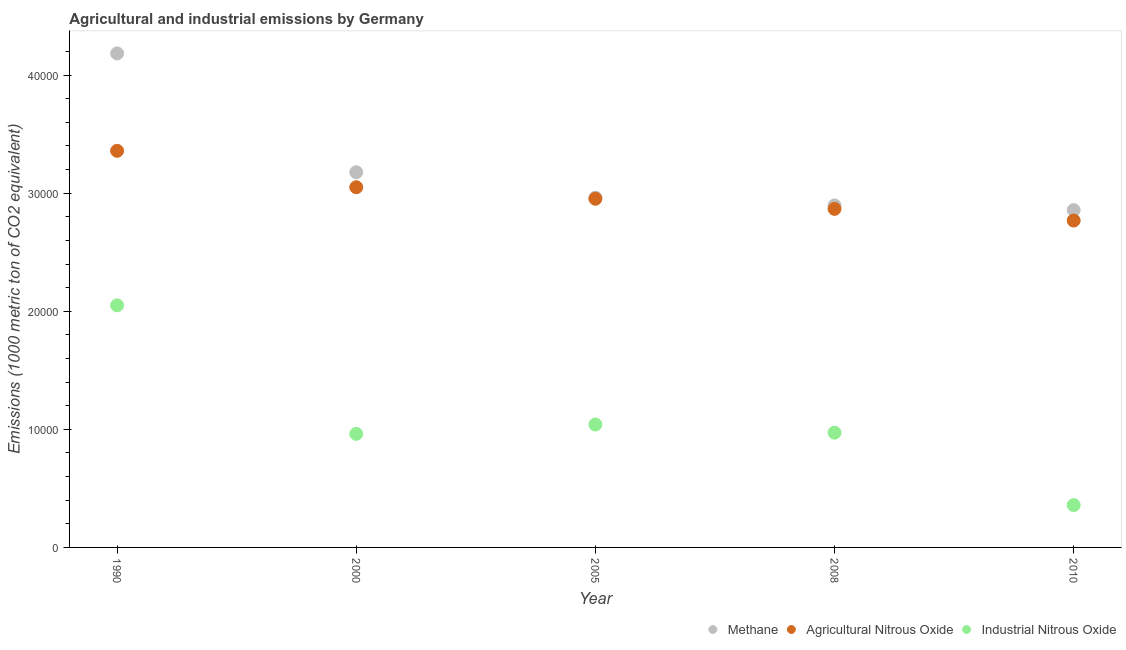What is the amount of agricultural nitrous oxide emissions in 2010?
Offer a very short reply. 2.77e+04. Across all years, what is the maximum amount of agricultural nitrous oxide emissions?
Ensure brevity in your answer.  3.36e+04. Across all years, what is the minimum amount of industrial nitrous oxide emissions?
Offer a very short reply. 3585.4. What is the total amount of agricultural nitrous oxide emissions in the graph?
Your answer should be very brief. 1.50e+05. What is the difference between the amount of agricultural nitrous oxide emissions in 2000 and that in 2005?
Your answer should be compact. 972.5. What is the difference between the amount of agricultural nitrous oxide emissions in 2000 and the amount of industrial nitrous oxide emissions in 2005?
Provide a succinct answer. 2.01e+04. What is the average amount of methane emissions per year?
Give a very brief answer. 3.21e+04. In the year 1990, what is the difference between the amount of industrial nitrous oxide emissions and amount of methane emissions?
Your response must be concise. -2.13e+04. In how many years, is the amount of agricultural nitrous oxide emissions greater than 2000 metric ton?
Offer a very short reply. 5. What is the ratio of the amount of industrial nitrous oxide emissions in 2005 to that in 2010?
Make the answer very short. 2.9. Is the difference between the amount of agricultural nitrous oxide emissions in 1990 and 2000 greater than the difference between the amount of methane emissions in 1990 and 2000?
Your response must be concise. No. What is the difference between the highest and the second highest amount of industrial nitrous oxide emissions?
Your answer should be compact. 1.01e+04. What is the difference between the highest and the lowest amount of industrial nitrous oxide emissions?
Provide a short and direct response. 1.69e+04. In how many years, is the amount of agricultural nitrous oxide emissions greater than the average amount of agricultural nitrous oxide emissions taken over all years?
Provide a short and direct response. 2. Is the sum of the amount of agricultural nitrous oxide emissions in 2000 and 2008 greater than the maximum amount of industrial nitrous oxide emissions across all years?
Make the answer very short. Yes. Is the amount of industrial nitrous oxide emissions strictly greater than the amount of agricultural nitrous oxide emissions over the years?
Give a very brief answer. No. How many dotlines are there?
Keep it short and to the point. 3. Where does the legend appear in the graph?
Ensure brevity in your answer.  Bottom right. How many legend labels are there?
Make the answer very short. 3. What is the title of the graph?
Your answer should be very brief. Agricultural and industrial emissions by Germany. Does "Non-communicable diseases" appear as one of the legend labels in the graph?
Your answer should be compact. No. What is the label or title of the Y-axis?
Make the answer very short. Emissions (1000 metric ton of CO2 equivalent). What is the Emissions (1000 metric ton of CO2 equivalent) of Methane in 1990?
Offer a terse response. 4.18e+04. What is the Emissions (1000 metric ton of CO2 equivalent) in Agricultural Nitrous Oxide in 1990?
Provide a succinct answer. 3.36e+04. What is the Emissions (1000 metric ton of CO2 equivalent) in Industrial Nitrous Oxide in 1990?
Your answer should be compact. 2.05e+04. What is the Emissions (1000 metric ton of CO2 equivalent) of Methane in 2000?
Offer a terse response. 3.18e+04. What is the Emissions (1000 metric ton of CO2 equivalent) of Agricultural Nitrous Oxide in 2000?
Offer a terse response. 3.05e+04. What is the Emissions (1000 metric ton of CO2 equivalent) of Industrial Nitrous Oxide in 2000?
Offer a very short reply. 9617.9. What is the Emissions (1000 metric ton of CO2 equivalent) of Methane in 2005?
Your answer should be compact. 2.96e+04. What is the Emissions (1000 metric ton of CO2 equivalent) of Agricultural Nitrous Oxide in 2005?
Keep it short and to the point. 2.95e+04. What is the Emissions (1000 metric ton of CO2 equivalent) in Industrial Nitrous Oxide in 2005?
Provide a short and direct response. 1.04e+04. What is the Emissions (1000 metric ton of CO2 equivalent) in Methane in 2008?
Give a very brief answer. 2.90e+04. What is the Emissions (1000 metric ton of CO2 equivalent) of Agricultural Nitrous Oxide in 2008?
Offer a very short reply. 2.87e+04. What is the Emissions (1000 metric ton of CO2 equivalent) in Industrial Nitrous Oxide in 2008?
Ensure brevity in your answer.  9718.4. What is the Emissions (1000 metric ton of CO2 equivalent) in Methane in 2010?
Offer a terse response. 2.86e+04. What is the Emissions (1000 metric ton of CO2 equivalent) in Agricultural Nitrous Oxide in 2010?
Provide a succinct answer. 2.77e+04. What is the Emissions (1000 metric ton of CO2 equivalent) of Industrial Nitrous Oxide in 2010?
Provide a short and direct response. 3585.4. Across all years, what is the maximum Emissions (1000 metric ton of CO2 equivalent) of Methane?
Provide a short and direct response. 4.18e+04. Across all years, what is the maximum Emissions (1000 metric ton of CO2 equivalent) in Agricultural Nitrous Oxide?
Your response must be concise. 3.36e+04. Across all years, what is the maximum Emissions (1000 metric ton of CO2 equivalent) of Industrial Nitrous Oxide?
Give a very brief answer. 2.05e+04. Across all years, what is the minimum Emissions (1000 metric ton of CO2 equivalent) of Methane?
Keep it short and to the point. 2.86e+04. Across all years, what is the minimum Emissions (1000 metric ton of CO2 equivalent) of Agricultural Nitrous Oxide?
Keep it short and to the point. 2.77e+04. Across all years, what is the minimum Emissions (1000 metric ton of CO2 equivalent) in Industrial Nitrous Oxide?
Offer a very short reply. 3585.4. What is the total Emissions (1000 metric ton of CO2 equivalent) of Methane in the graph?
Offer a very short reply. 1.61e+05. What is the total Emissions (1000 metric ton of CO2 equivalent) in Agricultural Nitrous Oxide in the graph?
Your answer should be very brief. 1.50e+05. What is the total Emissions (1000 metric ton of CO2 equivalent) in Industrial Nitrous Oxide in the graph?
Keep it short and to the point. 5.38e+04. What is the difference between the Emissions (1000 metric ton of CO2 equivalent) in Methane in 1990 and that in 2000?
Provide a succinct answer. 1.01e+04. What is the difference between the Emissions (1000 metric ton of CO2 equivalent) in Agricultural Nitrous Oxide in 1990 and that in 2000?
Offer a terse response. 3086.2. What is the difference between the Emissions (1000 metric ton of CO2 equivalent) in Industrial Nitrous Oxide in 1990 and that in 2000?
Give a very brief answer. 1.09e+04. What is the difference between the Emissions (1000 metric ton of CO2 equivalent) in Methane in 1990 and that in 2005?
Provide a succinct answer. 1.22e+04. What is the difference between the Emissions (1000 metric ton of CO2 equivalent) of Agricultural Nitrous Oxide in 1990 and that in 2005?
Offer a very short reply. 4058.7. What is the difference between the Emissions (1000 metric ton of CO2 equivalent) in Industrial Nitrous Oxide in 1990 and that in 2005?
Provide a succinct answer. 1.01e+04. What is the difference between the Emissions (1000 metric ton of CO2 equivalent) of Methane in 1990 and that in 2008?
Your answer should be compact. 1.29e+04. What is the difference between the Emissions (1000 metric ton of CO2 equivalent) in Agricultural Nitrous Oxide in 1990 and that in 2008?
Your response must be concise. 4916.5. What is the difference between the Emissions (1000 metric ton of CO2 equivalent) in Industrial Nitrous Oxide in 1990 and that in 2008?
Give a very brief answer. 1.08e+04. What is the difference between the Emissions (1000 metric ton of CO2 equivalent) of Methane in 1990 and that in 2010?
Provide a short and direct response. 1.33e+04. What is the difference between the Emissions (1000 metric ton of CO2 equivalent) of Agricultural Nitrous Oxide in 1990 and that in 2010?
Offer a very short reply. 5906.4. What is the difference between the Emissions (1000 metric ton of CO2 equivalent) in Industrial Nitrous Oxide in 1990 and that in 2010?
Your answer should be very brief. 1.69e+04. What is the difference between the Emissions (1000 metric ton of CO2 equivalent) in Methane in 2000 and that in 2005?
Make the answer very short. 2155.4. What is the difference between the Emissions (1000 metric ton of CO2 equivalent) of Agricultural Nitrous Oxide in 2000 and that in 2005?
Provide a succinct answer. 972.5. What is the difference between the Emissions (1000 metric ton of CO2 equivalent) of Industrial Nitrous Oxide in 2000 and that in 2005?
Offer a very short reply. -791. What is the difference between the Emissions (1000 metric ton of CO2 equivalent) of Methane in 2000 and that in 2008?
Offer a terse response. 2816.4. What is the difference between the Emissions (1000 metric ton of CO2 equivalent) in Agricultural Nitrous Oxide in 2000 and that in 2008?
Offer a very short reply. 1830.3. What is the difference between the Emissions (1000 metric ton of CO2 equivalent) in Industrial Nitrous Oxide in 2000 and that in 2008?
Your answer should be compact. -100.5. What is the difference between the Emissions (1000 metric ton of CO2 equivalent) in Methane in 2000 and that in 2010?
Your response must be concise. 3209.1. What is the difference between the Emissions (1000 metric ton of CO2 equivalent) in Agricultural Nitrous Oxide in 2000 and that in 2010?
Make the answer very short. 2820.2. What is the difference between the Emissions (1000 metric ton of CO2 equivalent) in Industrial Nitrous Oxide in 2000 and that in 2010?
Offer a terse response. 6032.5. What is the difference between the Emissions (1000 metric ton of CO2 equivalent) in Methane in 2005 and that in 2008?
Offer a very short reply. 661. What is the difference between the Emissions (1000 metric ton of CO2 equivalent) in Agricultural Nitrous Oxide in 2005 and that in 2008?
Offer a very short reply. 857.8. What is the difference between the Emissions (1000 metric ton of CO2 equivalent) in Industrial Nitrous Oxide in 2005 and that in 2008?
Your answer should be compact. 690.5. What is the difference between the Emissions (1000 metric ton of CO2 equivalent) of Methane in 2005 and that in 2010?
Provide a succinct answer. 1053.7. What is the difference between the Emissions (1000 metric ton of CO2 equivalent) of Agricultural Nitrous Oxide in 2005 and that in 2010?
Offer a terse response. 1847.7. What is the difference between the Emissions (1000 metric ton of CO2 equivalent) of Industrial Nitrous Oxide in 2005 and that in 2010?
Make the answer very short. 6823.5. What is the difference between the Emissions (1000 metric ton of CO2 equivalent) of Methane in 2008 and that in 2010?
Provide a succinct answer. 392.7. What is the difference between the Emissions (1000 metric ton of CO2 equivalent) of Agricultural Nitrous Oxide in 2008 and that in 2010?
Your response must be concise. 989.9. What is the difference between the Emissions (1000 metric ton of CO2 equivalent) of Industrial Nitrous Oxide in 2008 and that in 2010?
Offer a terse response. 6133. What is the difference between the Emissions (1000 metric ton of CO2 equivalent) of Methane in 1990 and the Emissions (1000 metric ton of CO2 equivalent) of Agricultural Nitrous Oxide in 2000?
Provide a short and direct response. 1.13e+04. What is the difference between the Emissions (1000 metric ton of CO2 equivalent) of Methane in 1990 and the Emissions (1000 metric ton of CO2 equivalent) of Industrial Nitrous Oxide in 2000?
Your answer should be very brief. 3.22e+04. What is the difference between the Emissions (1000 metric ton of CO2 equivalent) of Agricultural Nitrous Oxide in 1990 and the Emissions (1000 metric ton of CO2 equivalent) of Industrial Nitrous Oxide in 2000?
Your answer should be compact. 2.40e+04. What is the difference between the Emissions (1000 metric ton of CO2 equivalent) in Methane in 1990 and the Emissions (1000 metric ton of CO2 equivalent) in Agricultural Nitrous Oxide in 2005?
Ensure brevity in your answer.  1.23e+04. What is the difference between the Emissions (1000 metric ton of CO2 equivalent) of Methane in 1990 and the Emissions (1000 metric ton of CO2 equivalent) of Industrial Nitrous Oxide in 2005?
Provide a succinct answer. 3.14e+04. What is the difference between the Emissions (1000 metric ton of CO2 equivalent) in Agricultural Nitrous Oxide in 1990 and the Emissions (1000 metric ton of CO2 equivalent) in Industrial Nitrous Oxide in 2005?
Your answer should be compact. 2.32e+04. What is the difference between the Emissions (1000 metric ton of CO2 equivalent) of Methane in 1990 and the Emissions (1000 metric ton of CO2 equivalent) of Agricultural Nitrous Oxide in 2008?
Your answer should be compact. 1.32e+04. What is the difference between the Emissions (1000 metric ton of CO2 equivalent) of Methane in 1990 and the Emissions (1000 metric ton of CO2 equivalent) of Industrial Nitrous Oxide in 2008?
Your answer should be compact. 3.21e+04. What is the difference between the Emissions (1000 metric ton of CO2 equivalent) of Agricultural Nitrous Oxide in 1990 and the Emissions (1000 metric ton of CO2 equivalent) of Industrial Nitrous Oxide in 2008?
Offer a terse response. 2.39e+04. What is the difference between the Emissions (1000 metric ton of CO2 equivalent) of Methane in 1990 and the Emissions (1000 metric ton of CO2 equivalent) of Agricultural Nitrous Oxide in 2010?
Provide a succinct answer. 1.42e+04. What is the difference between the Emissions (1000 metric ton of CO2 equivalent) of Methane in 1990 and the Emissions (1000 metric ton of CO2 equivalent) of Industrial Nitrous Oxide in 2010?
Offer a very short reply. 3.83e+04. What is the difference between the Emissions (1000 metric ton of CO2 equivalent) of Agricultural Nitrous Oxide in 1990 and the Emissions (1000 metric ton of CO2 equivalent) of Industrial Nitrous Oxide in 2010?
Your answer should be very brief. 3.00e+04. What is the difference between the Emissions (1000 metric ton of CO2 equivalent) in Methane in 2000 and the Emissions (1000 metric ton of CO2 equivalent) in Agricultural Nitrous Oxide in 2005?
Your answer should be compact. 2246. What is the difference between the Emissions (1000 metric ton of CO2 equivalent) in Methane in 2000 and the Emissions (1000 metric ton of CO2 equivalent) in Industrial Nitrous Oxide in 2005?
Your response must be concise. 2.14e+04. What is the difference between the Emissions (1000 metric ton of CO2 equivalent) of Agricultural Nitrous Oxide in 2000 and the Emissions (1000 metric ton of CO2 equivalent) of Industrial Nitrous Oxide in 2005?
Give a very brief answer. 2.01e+04. What is the difference between the Emissions (1000 metric ton of CO2 equivalent) in Methane in 2000 and the Emissions (1000 metric ton of CO2 equivalent) in Agricultural Nitrous Oxide in 2008?
Your answer should be compact. 3103.8. What is the difference between the Emissions (1000 metric ton of CO2 equivalent) in Methane in 2000 and the Emissions (1000 metric ton of CO2 equivalent) in Industrial Nitrous Oxide in 2008?
Your answer should be very brief. 2.21e+04. What is the difference between the Emissions (1000 metric ton of CO2 equivalent) in Agricultural Nitrous Oxide in 2000 and the Emissions (1000 metric ton of CO2 equivalent) in Industrial Nitrous Oxide in 2008?
Offer a terse response. 2.08e+04. What is the difference between the Emissions (1000 metric ton of CO2 equivalent) of Methane in 2000 and the Emissions (1000 metric ton of CO2 equivalent) of Agricultural Nitrous Oxide in 2010?
Provide a succinct answer. 4093.7. What is the difference between the Emissions (1000 metric ton of CO2 equivalent) in Methane in 2000 and the Emissions (1000 metric ton of CO2 equivalent) in Industrial Nitrous Oxide in 2010?
Your response must be concise. 2.82e+04. What is the difference between the Emissions (1000 metric ton of CO2 equivalent) of Agricultural Nitrous Oxide in 2000 and the Emissions (1000 metric ton of CO2 equivalent) of Industrial Nitrous Oxide in 2010?
Provide a succinct answer. 2.69e+04. What is the difference between the Emissions (1000 metric ton of CO2 equivalent) of Methane in 2005 and the Emissions (1000 metric ton of CO2 equivalent) of Agricultural Nitrous Oxide in 2008?
Offer a terse response. 948.4. What is the difference between the Emissions (1000 metric ton of CO2 equivalent) of Methane in 2005 and the Emissions (1000 metric ton of CO2 equivalent) of Industrial Nitrous Oxide in 2008?
Provide a succinct answer. 1.99e+04. What is the difference between the Emissions (1000 metric ton of CO2 equivalent) in Agricultural Nitrous Oxide in 2005 and the Emissions (1000 metric ton of CO2 equivalent) in Industrial Nitrous Oxide in 2008?
Ensure brevity in your answer.  1.98e+04. What is the difference between the Emissions (1000 metric ton of CO2 equivalent) in Methane in 2005 and the Emissions (1000 metric ton of CO2 equivalent) in Agricultural Nitrous Oxide in 2010?
Make the answer very short. 1938.3. What is the difference between the Emissions (1000 metric ton of CO2 equivalent) in Methane in 2005 and the Emissions (1000 metric ton of CO2 equivalent) in Industrial Nitrous Oxide in 2010?
Offer a terse response. 2.60e+04. What is the difference between the Emissions (1000 metric ton of CO2 equivalent) in Agricultural Nitrous Oxide in 2005 and the Emissions (1000 metric ton of CO2 equivalent) in Industrial Nitrous Oxide in 2010?
Offer a terse response. 2.59e+04. What is the difference between the Emissions (1000 metric ton of CO2 equivalent) in Methane in 2008 and the Emissions (1000 metric ton of CO2 equivalent) in Agricultural Nitrous Oxide in 2010?
Your answer should be compact. 1277.3. What is the difference between the Emissions (1000 metric ton of CO2 equivalent) in Methane in 2008 and the Emissions (1000 metric ton of CO2 equivalent) in Industrial Nitrous Oxide in 2010?
Your answer should be compact. 2.54e+04. What is the difference between the Emissions (1000 metric ton of CO2 equivalent) of Agricultural Nitrous Oxide in 2008 and the Emissions (1000 metric ton of CO2 equivalent) of Industrial Nitrous Oxide in 2010?
Offer a very short reply. 2.51e+04. What is the average Emissions (1000 metric ton of CO2 equivalent) of Methane per year?
Make the answer very short. 3.21e+04. What is the average Emissions (1000 metric ton of CO2 equivalent) of Agricultural Nitrous Oxide per year?
Provide a succinct answer. 3.00e+04. What is the average Emissions (1000 metric ton of CO2 equivalent) in Industrial Nitrous Oxide per year?
Provide a succinct answer. 1.08e+04. In the year 1990, what is the difference between the Emissions (1000 metric ton of CO2 equivalent) in Methane and Emissions (1000 metric ton of CO2 equivalent) in Agricultural Nitrous Oxide?
Keep it short and to the point. 8249.3. In the year 1990, what is the difference between the Emissions (1000 metric ton of CO2 equivalent) in Methane and Emissions (1000 metric ton of CO2 equivalent) in Industrial Nitrous Oxide?
Give a very brief answer. 2.13e+04. In the year 1990, what is the difference between the Emissions (1000 metric ton of CO2 equivalent) of Agricultural Nitrous Oxide and Emissions (1000 metric ton of CO2 equivalent) of Industrial Nitrous Oxide?
Your response must be concise. 1.31e+04. In the year 2000, what is the difference between the Emissions (1000 metric ton of CO2 equivalent) of Methane and Emissions (1000 metric ton of CO2 equivalent) of Agricultural Nitrous Oxide?
Your response must be concise. 1273.5. In the year 2000, what is the difference between the Emissions (1000 metric ton of CO2 equivalent) of Methane and Emissions (1000 metric ton of CO2 equivalent) of Industrial Nitrous Oxide?
Provide a succinct answer. 2.22e+04. In the year 2000, what is the difference between the Emissions (1000 metric ton of CO2 equivalent) of Agricultural Nitrous Oxide and Emissions (1000 metric ton of CO2 equivalent) of Industrial Nitrous Oxide?
Your answer should be very brief. 2.09e+04. In the year 2005, what is the difference between the Emissions (1000 metric ton of CO2 equivalent) of Methane and Emissions (1000 metric ton of CO2 equivalent) of Agricultural Nitrous Oxide?
Your answer should be compact. 90.6. In the year 2005, what is the difference between the Emissions (1000 metric ton of CO2 equivalent) in Methane and Emissions (1000 metric ton of CO2 equivalent) in Industrial Nitrous Oxide?
Your response must be concise. 1.92e+04. In the year 2005, what is the difference between the Emissions (1000 metric ton of CO2 equivalent) of Agricultural Nitrous Oxide and Emissions (1000 metric ton of CO2 equivalent) of Industrial Nitrous Oxide?
Ensure brevity in your answer.  1.91e+04. In the year 2008, what is the difference between the Emissions (1000 metric ton of CO2 equivalent) of Methane and Emissions (1000 metric ton of CO2 equivalent) of Agricultural Nitrous Oxide?
Provide a succinct answer. 287.4. In the year 2008, what is the difference between the Emissions (1000 metric ton of CO2 equivalent) of Methane and Emissions (1000 metric ton of CO2 equivalent) of Industrial Nitrous Oxide?
Keep it short and to the point. 1.92e+04. In the year 2008, what is the difference between the Emissions (1000 metric ton of CO2 equivalent) of Agricultural Nitrous Oxide and Emissions (1000 metric ton of CO2 equivalent) of Industrial Nitrous Oxide?
Make the answer very short. 1.90e+04. In the year 2010, what is the difference between the Emissions (1000 metric ton of CO2 equivalent) in Methane and Emissions (1000 metric ton of CO2 equivalent) in Agricultural Nitrous Oxide?
Keep it short and to the point. 884.6. In the year 2010, what is the difference between the Emissions (1000 metric ton of CO2 equivalent) of Methane and Emissions (1000 metric ton of CO2 equivalent) of Industrial Nitrous Oxide?
Offer a terse response. 2.50e+04. In the year 2010, what is the difference between the Emissions (1000 metric ton of CO2 equivalent) of Agricultural Nitrous Oxide and Emissions (1000 metric ton of CO2 equivalent) of Industrial Nitrous Oxide?
Your answer should be compact. 2.41e+04. What is the ratio of the Emissions (1000 metric ton of CO2 equivalent) in Methane in 1990 to that in 2000?
Ensure brevity in your answer.  1.32. What is the ratio of the Emissions (1000 metric ton of CO2 equivalent) in Agricultural Nitrous Oxide in 1990 to that in 2000?
Your answer should be compact. 1.1. What is the ratio of the Emissions (1000 metric ton of CO2 equivalent) of Industrial Nitrous Oxide in 1990 to that in 2000?
Provide a short and direct response. 2.13. What is the ratio of the Emissions (1000 metric ton of CO2 equivalent) in Methane in 1990 to that in 2005?
Offer a terse response. 1.41. What is the ratio of the Emissions (1000 metric ton of CO2 equivalent) in Agricultural Nitrous Oxide in 1990 to that in 2005?
Ensure brevity in your answer.  1.14. What is the ratio of the Emissions (1000 metric ton of CO2 equivalent) in Industrial Nitrous Oxide in 1990 to that in 2005?
Make the answer very short. 1.97. What is the ratio of the Emissions (1000 metric ton of CO2 equivalent) of Methane in 1990 to that in 2008?
Make the answer very short. 1.44. What is the ratio of the Emissions (1000 metric ton of CO2 equivalent) of Agricultural Nitrous Oxide in 1990 to that in 2008?
Your response must be concise. 1.17. What is the ratio of the Emissions (1000 metric ton of CO2 equivalent) in Industrial Nitrous Oxide in 1990 to that in 2008?
Offer a very short reply. 2.11. What is the ratio of the Emissions (1000 metric ton of CO2 equivalent) in Methane in 1990 to that in 2010?
Your answer should be compact. 1.46. What is the ratio of the Emissions (1000 metric ton of CO2 equivalent) in Agricultural Nitrous Oxide in 1990 to that in 2010?
Provide a succinct answer. 1.21. What is the ratio of the Emissions (1000 metric ton of CO2 equivalent) in Industrial Nitrous Oxide in 1990 to that in 2010?
Your answer should be compact. 5.72. What is the ratio of the Emissions (1000 metric ton of CO2 equivalent) in Methane in 2000 to that in 2005?
Provide a succinct answer. 1.07. What is the ratio of the Emissions (1000 metric ton of CO2 equivalent) in Agricultural Nitrous Oxide in 2000 to that in 2005?
Offer a terse response. 1.03. What is the ratio of the Emissions (1000 metric ton of CO2 equivalent) in Industrial Nitrous Oxide in 2000 to that in 2005?
Your answer should be very brief. 0.92. What is the ratio of the Emissions (1000 metric ton of CO2 equivalent) of Methane in 2000 to that in 2008?
Provide a short and direct response. 1.1. What is the ratio of the Emissions (1000 metric ton of CO2 equivalent) of Agricultural Nitrous Oxide in 2000 to that in 2008?
Make the answer very short. 1.06. What is the ratio of the Emissions (1000 metric ton of CO2 equivalent) in Methane in 2000 to that in 2010?
Offer a very short reply. 1.11. What is the ratio of the Emissions (1000 metric ton of CO2 equivalent) in Agricultural Nitrous Oxide in 2000 to that in 2010?
Your answer should be very brief. 1.1. What is the ratio of the Emissions (1000 metric ton of CO2 equivalent) in Industrial Nitrous Oxide in 2000 to that in 2010?
Ensure brevity in your answer.  2.68. What is the ratio of the Emissions (1000 metric ton of CO2 equivalent) in Methane in 2005 to that in 2008?
Your answer should be compact. 1.02. What is the ratio of the Emissions (1000 metric ton of CO2 equivalent) of Agricultural Nitrous Oxide in 2005 to that in 2008?
Make the answer very short. 1.03. What is the ratio of the Emissions (1000 metric ton of CO2 equivalent) in Industrial Nitrous Oxide in 2005 to that in 2008?
Your answer should be compact. 1.07. What is the ratio of the Emissions (1000 metric ton of CO2 equivalent) in Methane in 2005 to that in 2010?
Give a very brief answer. 1.04. What is the ratio of the Emissions (1000 metric ton of CO2 equivalent) of Agricultural Nitrous Oxide in 2005 to that in 2010?
Ensure brevity in your answer.  1.07. What is the ratio of the Emissions (1000 metric ton of CO2 equivalent) of Industrial Nitrous Oxide in 2005 to that in 2010?
Make the answer very short. 2.9. What is the ratio of the Emissions (1000 metric ton of CO2 equivalent) of Methane in 2008 to that in 2010?
Ensure brevity in your answer.  1.01. What is the ratio of the Emissions (1000 metric ton of CO2 equivalent) in Agricultural Nitrous Oxide in 2008 to that in 2010?
Provide a succinct answer. 1.04. What is the ratio of the Emissions (1000 metric ton of CO2 equivalent) of Industrial Nitrous Oxide in 2008 to that in 2010?
Offer a terse response. 2.71. What is the difference between the highest and the second highest Emissions (1000 metric ton of CO2 equivalent) of Methane?
Your answer should be compact. 1.01e+04. What is the difference between the highest and the second highest Emissions (1000 metric ton of CO2 equivalent) of Agricultural Nitrous Oxide?
Your response must be concise. 3086.2. What is the difference between the highest and the second highest Emissions (1000 metric ton of CO2 equivalent) in Industrial Nitrous Oxide?
Give a very brief answer. 1.01e+04. What is the difference between the highest and the lowest Emissions (1000 metric ton of CO2 equivalent) of Methane?
Keep it short and to the point. 1.33e+04. What is the difference between the highest and the lowest Emissions (1000 metric ton of CO2 equivalent) in Agricultural Nitrous Oxide?
Give a very brief answer. 5906.4. What is the difference between the highest and the lowest Emissions (1000 metric ton of CO2 equivalent) of Industrial Nitrous Oxide?
Make the answer very short. 1.69e+04. 